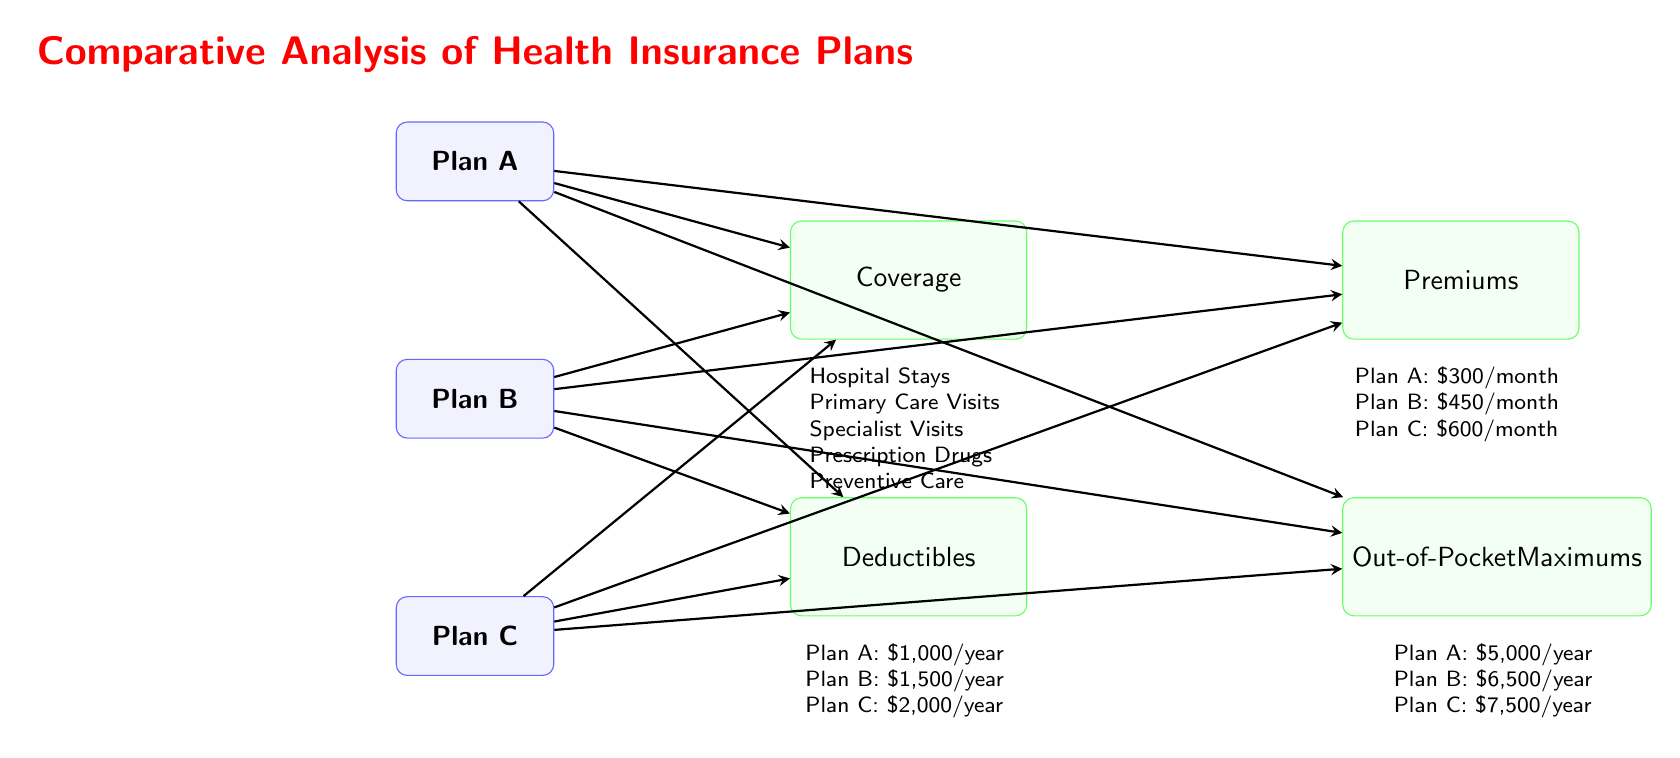What does Plan A cost in monthly premiums? According to the diagram, the monthly premium for Plan A is listed directly under the "Premiums" feature. It states: "Plan A: \$300/month."
Answer: \$300/month What is the annual deductible for Plan B? The annual deductible for Plan B can be found under the "Deductibles" feature. It specifically states: "Plan B: \$1,500/year."
Answer: \$1,500/year How many health insurance plans are compared in the diagram? The diagram displays three distinct plans: Plan A, Plan B, and Plan C. Therefore, the number of health insurance plans compared is three.
Answer: 3 Which plan has the highest out-of-pocket maximum? To find which plan has the highest out-of-pocket maximum, I compare the values listed under "Out-of-Pocket Maximums." It states: "Plan C: \$7,500/year," which is greater than the amounts for Plans A and B.
Answer: Plan C What type of coverage does the diagram mention for all plans? The diagram lists the types of coverage common to all plans under the "Coverage" feature. These include hospital stays, primary care visits, specialist visits, prescription drugs, and preventive care.
Answer: Hospital Stays, Primary Care Visits, Specialist Visits, Prescription Drugs, Preventive Care What is the difference in monthly premiums between Plan A and Plan C? The monthly premiums for Plan A and Plan C are stated as follows: Plan A is \$300/month and Plan C is \$600/month. To find the difference, I subtract these two amounts: \$600 - \$300 = \$300.
Answer: \$300 Which plan has the lowest out-of-pocket maximum? The out-of-pocket maximum for each plan is listed: Plan A has \$5,000, Plan B has \$6,500, and Plan C has \$7,500. Comparing these, Plan A has the lowest out-of-pocket maximum.
Answer: Plan A What is the range of annual deductibles across the plans? The annual deductibles are specified for each plan: Plan A is \$1,000/year, Plan B is \$1,500/year, and Plan C is \$2,000/year. The range can be determined by finding the difference between the lowest and highest values, which is \$2,000 - \$1,000 = \$1,000.
Answer: \$1,000 Which insurance plan offers the most comprehensive coverage based on the features listed? The coverage under the "Coverage" feature is the same for all plans. Therefore, the most comprehensive coverage cannot be determined solely based on the features listed in this diagram, as they all cover the same services.
Answer: N/A 